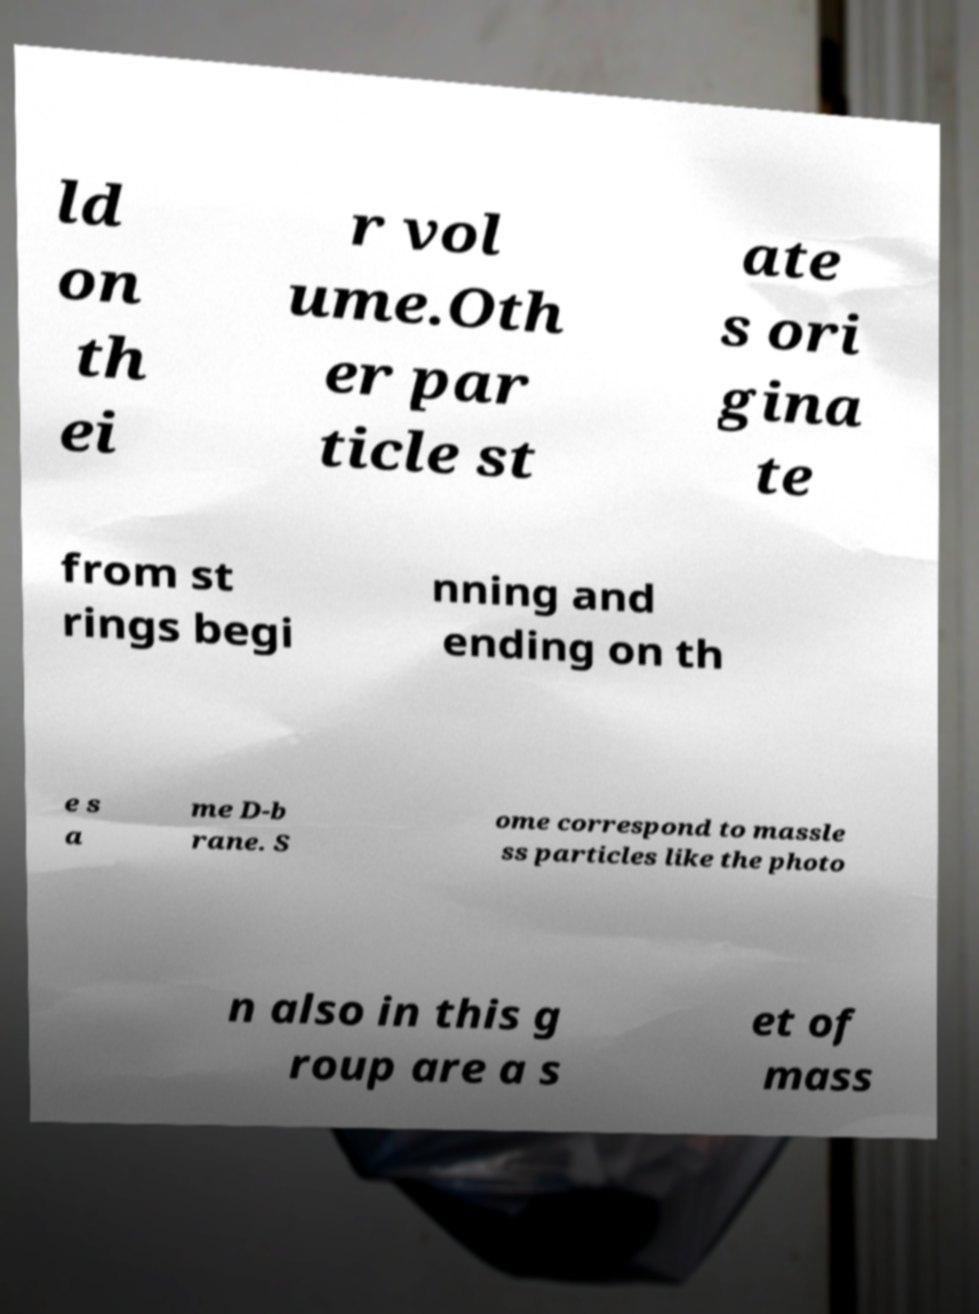Can you read and provide the text displayed in the image?This photo seems to have some interesting text. Can you extract and type it out for me? ld on th ei r vol ume.Oth er par ticle st ate s ori gina te from st rings begi nning and ending on th e s a me D-b rane. S ome correspond to massle ss particles like the photo n also in this g roup are a s et of mass 